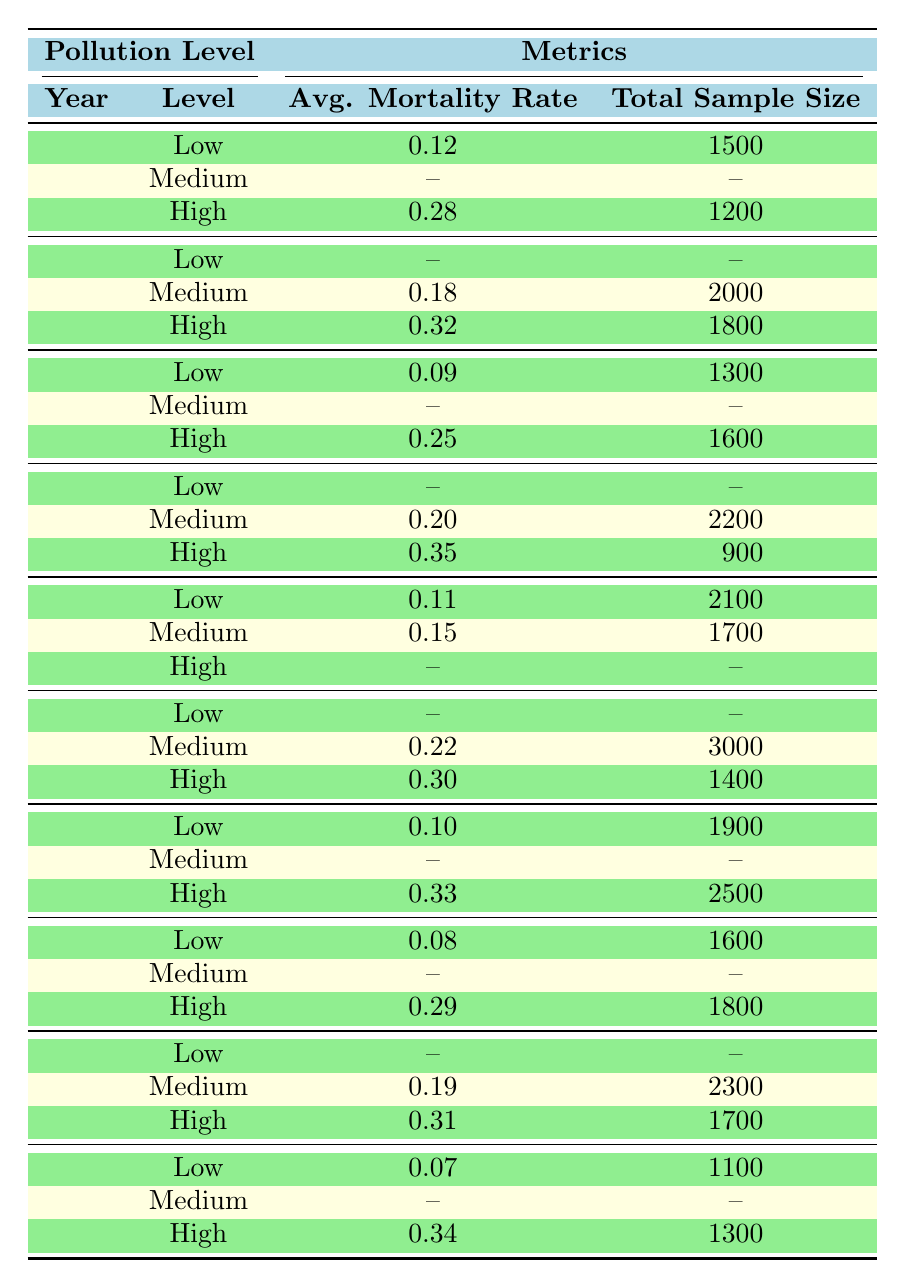What is the average mortality rate for fish in polluted ecosystems in 2010? In 2010, the only polluted ecosystem listed is the Hudson River, which has a mortality rate of 0.28. Since there is only one entry, the average is also 0.28.
Answer: 0.28 What is the total sample size for fish in non-polluted ecosystems over the decade? The non-polluted ecosystems listed in the table are Lake Michigan, Lake Superior, Lake Erie, Lake Ontario, and Lake Huron. Their sample sizes are 1500, 1300, 2100, 1900, and 1600 respectively. Adding these gives 1500 + 1300 + 2100 + 1900 + 1600 = 10300.
Answer: 10300 Is the mortality rate for fish in polluted ecosystems generally higher than in non-polluted ecosystems based on the data? By examining the available years, the average mortality rates for polluted ecosystems are greater than for non-polluted from 2010 to 2019. Thus, overall, the conclusion is yes.
Answer: Yes What was the year with the highest average mortality rate in polluted ecosystems? Reviewing the average mortality rates for high pollution levels across the years, 2013 has the highest average rate at 0.35 (from the Atlantic Sturgeon).
Answer: 2013 What is the average mortality rate for fish in medium pollution levels over the entire decade? The medium pollution levels occur in 2011 (0.18), 2012 (0.20), 2014 (0.15), 2015 (0.22), and 2018 (0.19). To find the average, we sum these values giving 0.18 + 0.20 + 0.15 + 0.22 + 0.19 = 1.04, then divide by the number of entries, which is 5. Therefore, the average is 1.04 / 5 = 0.208.
Answer: 0.208 How many years reported fish mortality rates for low pollution levels? The years reporting fish mortality rates for low pollution levels are 2010 (0.12), 2012 (0.09), 2014 (0.11), 2016 (0.10), and 2017 (0.08). This totals to 5 years.
Answer: 5 What was the total sample size for the year with the highest pollution level recorded? The highest mortality rate recorded was 0.35 in 2013 from a polluted ecosystem (Delaware Bay) with a total sample size of 900. This represents the total sample size for the year with the highest pollution level.
Answer: 900 What is the difference in average mortality rates between high and low pollution ecosystems in 2015? In 2015, the high pollution level had a mortality rate of 0.30 and low pollution had no recorded value. Since we cannot calculate a difference (as one is not defined), it effectively yields no answer or is irrelevant.
Answer: Not applicable What is the total sample size across all ecosystems in 2017? Analyzing 2017, we observe sample sizes of 1600 from Lake Huron (low pollution) and 1800 from Ohio River (high pollution). Thus, the total sample size is 1600 + 1800 = 3400.
Answer: 3400 